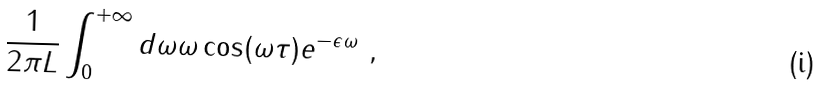<formula> <loc_0><loc_0><loc_500><loc_500>\frac { 1 } { 2 \pi L } \int _ { 0 } ^ { + \infty } d \omega \omega \cos ( \omega \tau ) e ^ { - \epsilon \omega } \ ,</formula> 